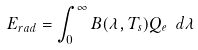Convert formula to latex. <formula><loc_0><loc_0><loc_500><loc_500>E _ { r a d } = \int _ { 0 } ^ { \infty } B ( \lambda , T _ { s } ) Q _ { e } \ d \lambda</formula> 